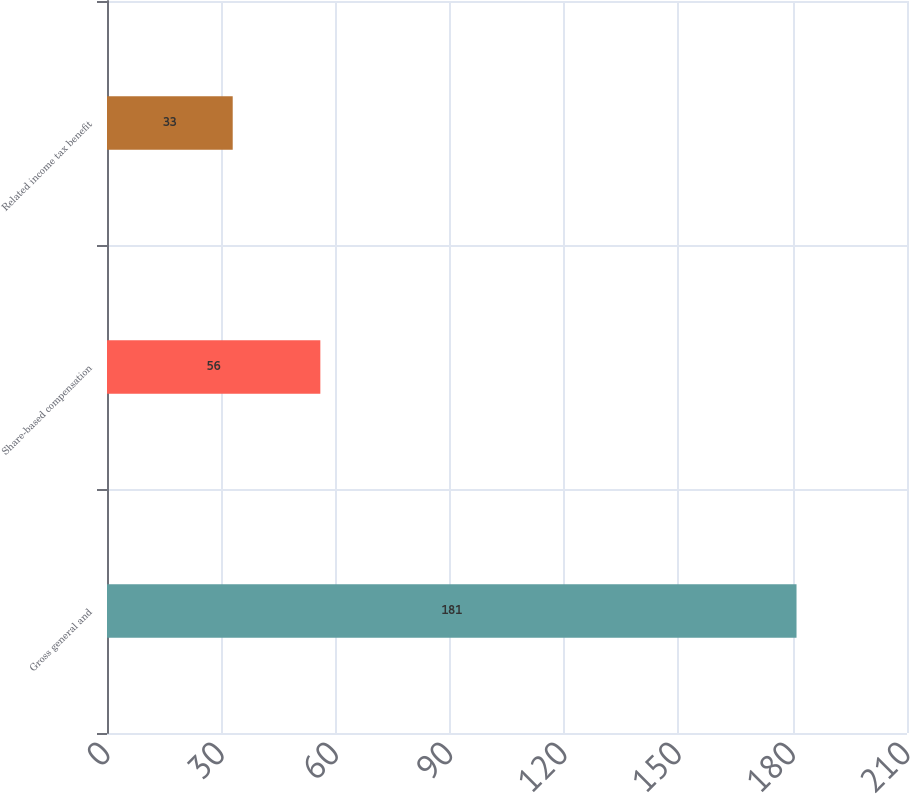<chart> <loc_0><loc_0><loc_500><loc_500><bar_chart><fcel>Gross general and<fcel>Share-based compensation<fcel>Related income tax benefit<nl><fcel>181<fcel>56<fcel>33<nl></chart> 